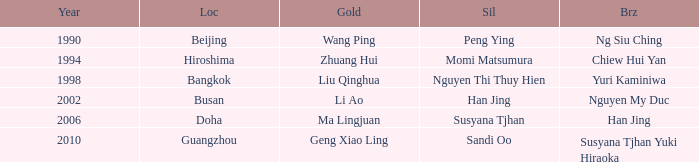What Gold has the Year of 2006? Ma Lingjuan. 